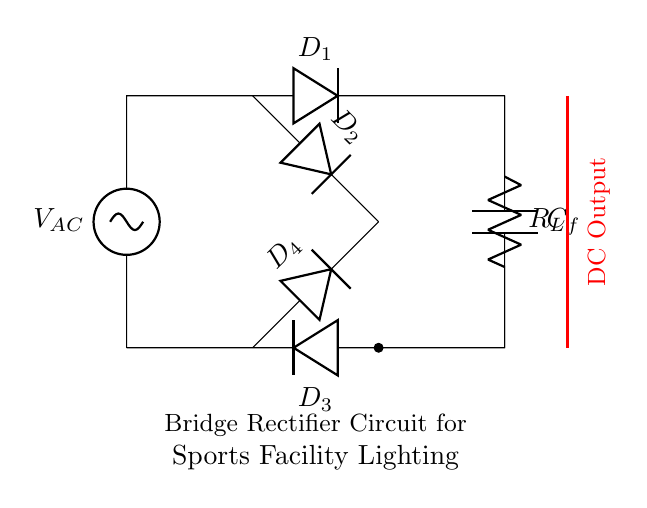What is the type of rectifier used in this circuit? This circuit is a bridge rectifier, composed of four diodes arranged in a bridge configuration. This configuration allows both halves of the AC waveform to be converted into DC.
Answer: bridge rectifier How many diodes are present in the circuit? The circuit contains four diodes, labeled D1, D2, D3, and D4. Each diode plays a role in rectifying the current.
Answer: four What is the function of the capacitor in this circuit? The capacitor, labeled C_f, functions as a filter that smooths the output voltage from the rectifier. It reduces ripple in the DC output, improving the quality of the power supplied to the lighting system.
Answer: filter What type of load is this circuit designed to support? The circuit includes a load resistor, labeled R_L, which is indicative of supporting resistive loads such as lights in a sports facility. The resistor represents the lighting system being powered.
Answer: lighting system What is the DC output connection status in this circuit? The DC output is indicated with a red line, showing it is connected to the load that utilizes the rectified current. This means the circuit is designed to provide a usable DC output voltage for the lighting.
Answer: connected 